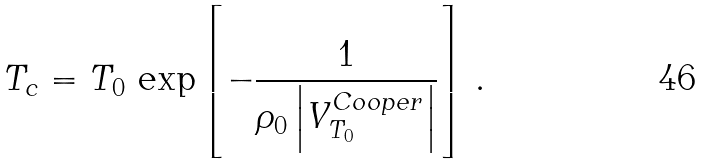<formula> <loc_0><loc_0><loc_500><loc_500>T _ { c } = T _ { 0 } \, \exp \left [ - \frac { 1 } { \rho _ { 0 } \left | V ^ { C o o p e r } _ { T _ { 0 } } \right | } \right ] \, .</formula> 